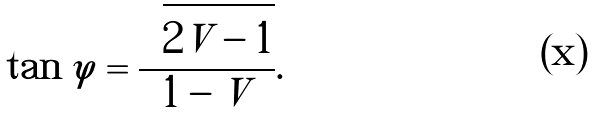<formula> <loc_0><loc_0><loc_500><loc_500>\text { } \tan \varphi = \frac { \sqrt { 2 V - 1 } } { 1 - V } .</formula> 